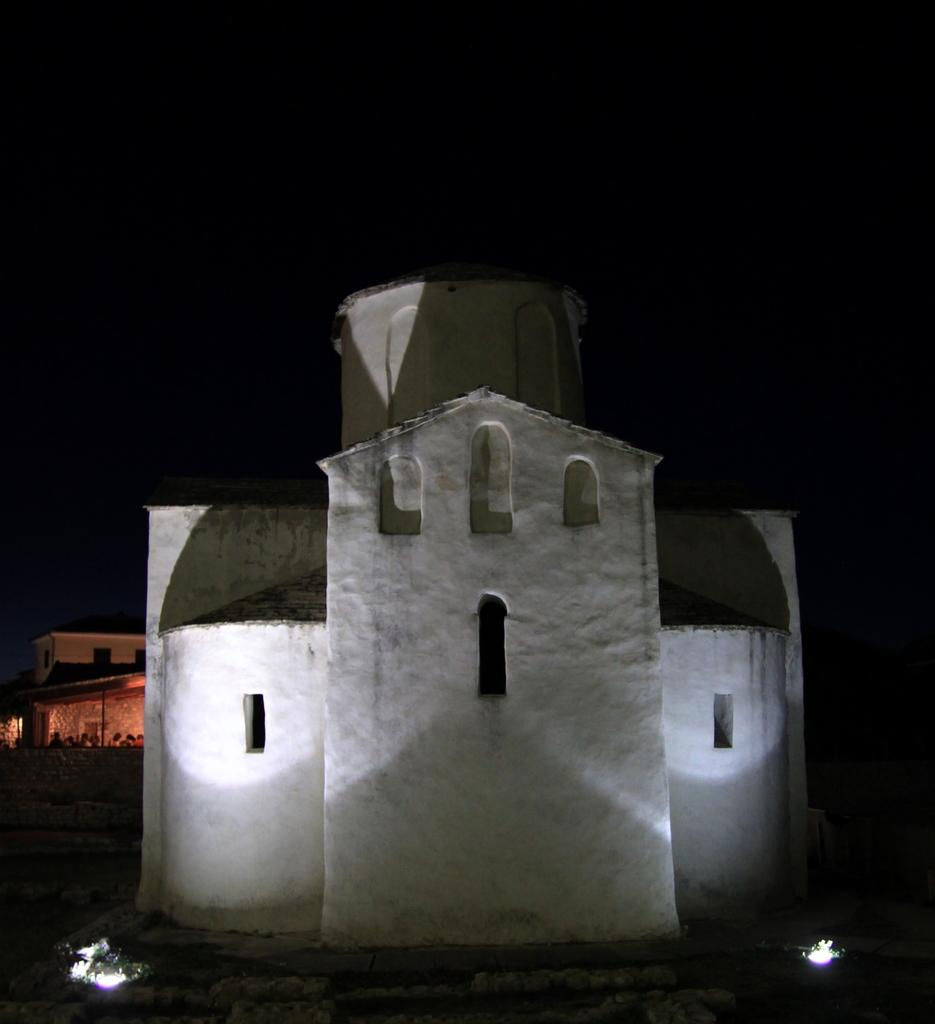What type of structures can be seen in the image? There are buildings in the image. Can you describe any additional features at the bottom of the image? Yes, there are lights at the bottom of the image. What type of mint is being discussed in the meeting depicted in the image? There is no meeting or mint present in the image; it only features buildings and lights. 